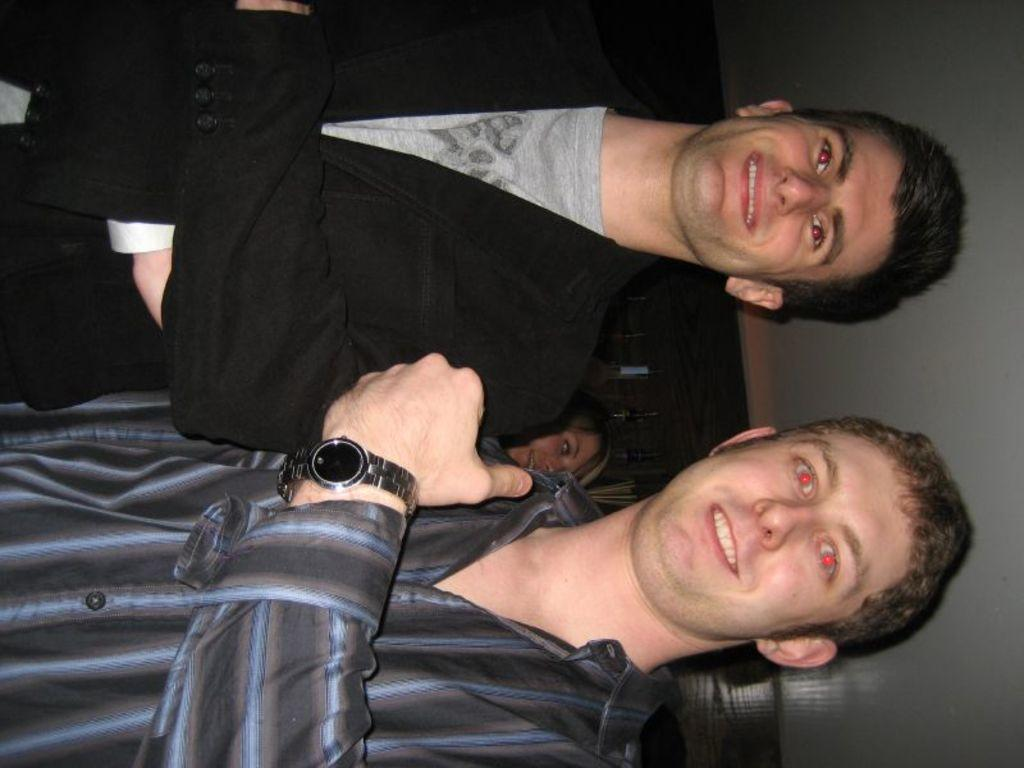What are the two men in the image doing? The two men in the image are standing and smiling. Can you describe the clothing of one of the men? One of the men is wearing a shirt. What accessory is visible on one of the men? One of the men is wearing a wrist watch. Who else can be seen in the image besides the two men? There is a woman visible behind the two men. Where does the scene appear to be taking place? The scene appears to be on a roof. What type of roll can be seen on the roof in the image? There is no roll present in the image; it features two men standing and smiling, a woman, and a roof setting. What scale is used to measure the size of the wrist watch in the image? There is no scale present in the image, and the size of the wrist watch is not being measured. 